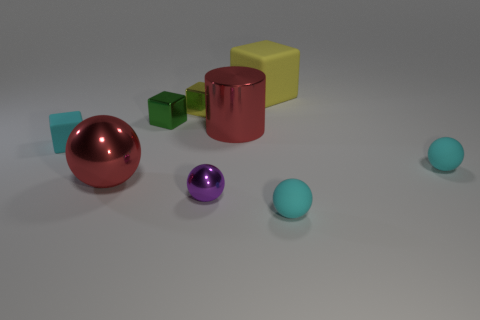The yellow matte object that is the same shape as the green object is what size?
Your answer should be very brief. Large. How many small matte things are both behind the small purple metallic ball and right of the large block?
Provide a short and direct response. 1. There is a tiny purple thing; is it the same shape as the red thing to the left of the tiny yellow thing?
Make the answer very short. Yes. Are there more big objects that are in front of the big cylinder than tiny red metal cylinders?
Your response must be concise. Yes. Is the number of cyan matte cubes to the right of the large red shiny cylinder less than the number of purple matte spheres?
Make the answer very short. No. How many balls are the same color as the big cylinder?
Your answer should be very brief. 1. The cyan thing that is behind the purple object and in front of the cyan matte block is made of what material?
Ensure brevity in your answer.  Rubber. There is a big object on the left side of the green cube; is its color the same as the large shiny thing that is to the right of the large red sphere?
Offer a very short reply. Yes. How many red things are shiny cylinders or large metal spheres?
Offer a terse response. 2. Are there fewer large red spheres that are in front of the green cube than things on the right side of the purple metallic object?
Make the answer very short. Yes. 